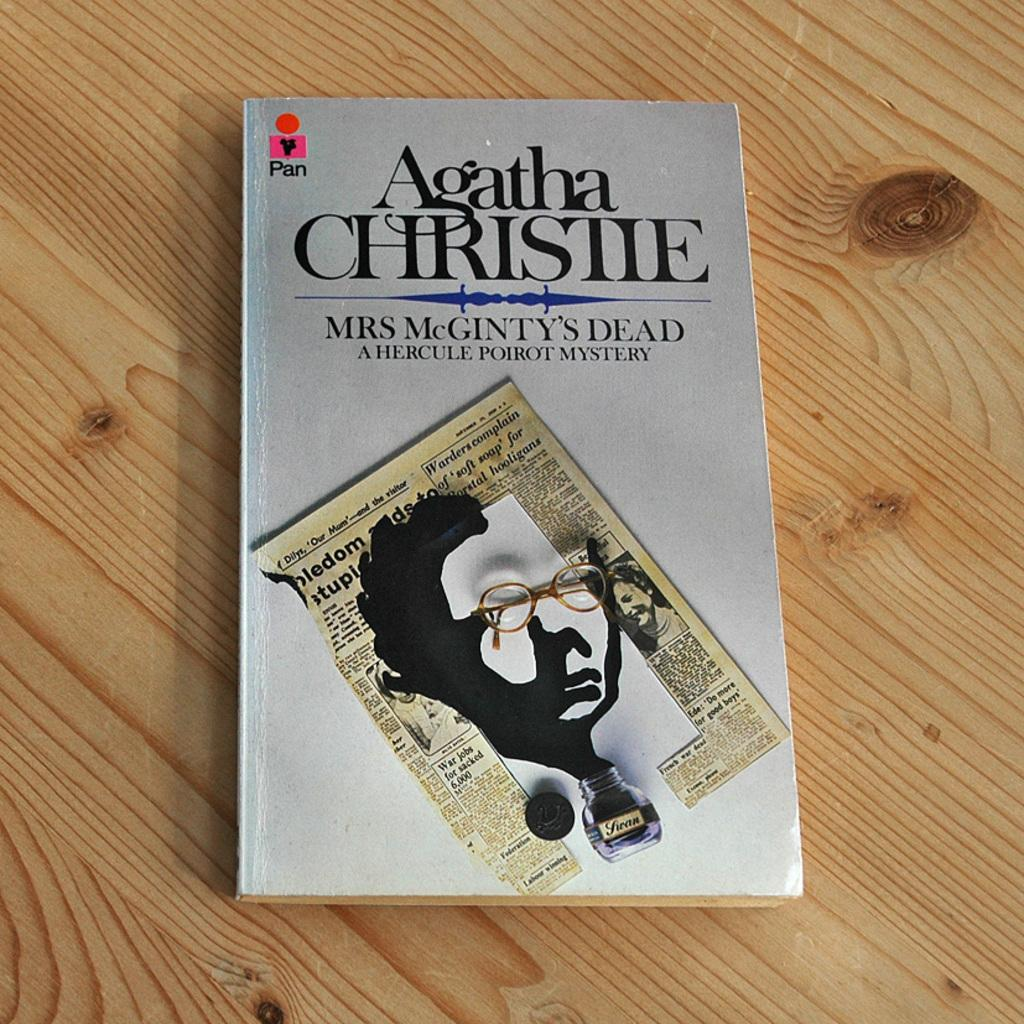What is placed on the wooden surface in the image? There is a book on a wooden surface. What is on top of the book? There is a paper and a bottle on the book. Can you read any text in the image? Yes, there is text visible on the book or paper. What type of chin can be seen on the basketball in the image? There is no basketball present in the image, so there is no chin to be seen. 